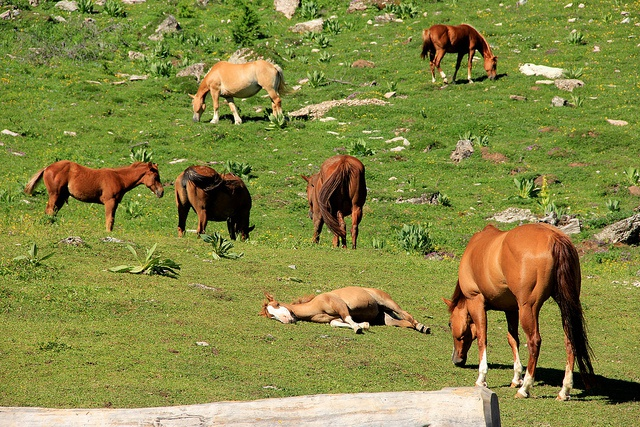Describe the objects in this image and their specific colors. I can see horse in olive, black, orange, red, and brown tones, horse in olive, tan, and black tones, horse in olive, brown, black, and maroon tones, horse in olive, black, brown, and maroon tones, and horse in olive, black, maroon, brown, and salmon tones in this image. 